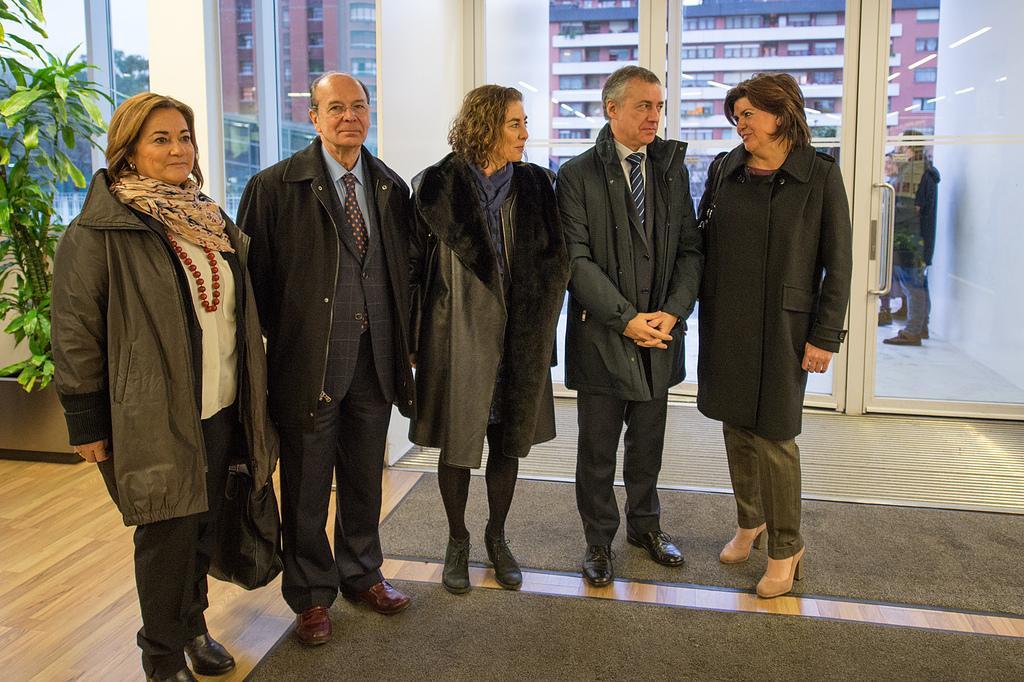Describe this image in one or two sentences. In this image we can see a group of people standing on the floor. We can also see a plant, window and a glass door with a handle. On the backside we can see some trees, a building, some people standing and the sky. 